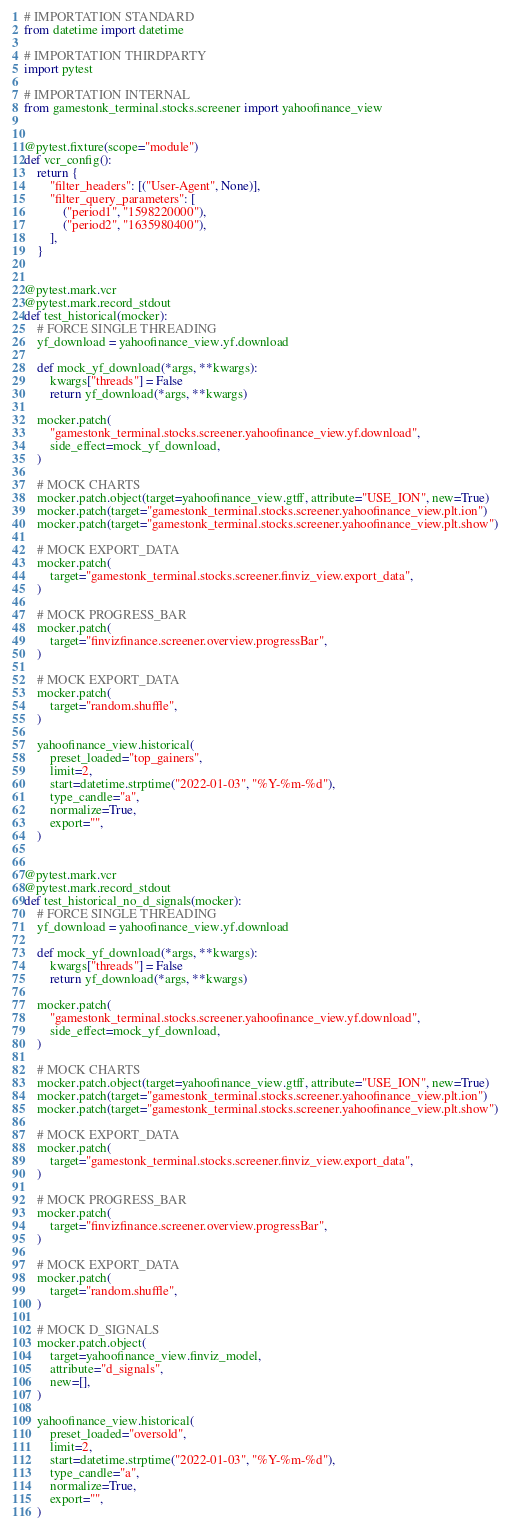<code> <loc_0><loc_0><loc_500><loc_500><_Python_># IMPORTATION STANDARD
from datetime import datetime

# IMPORTATION THIRDPARTY
import pytest

# IMPORTATION INTERNAL
from gamestonk_terminal.stocks.screener import yahoofinance_view


@pytest.fixture(scope="module")
def vcr_config():
    return {
        "filter_headers": [("User-Agent", None)],
        "filter_query_parameters": [
            ("period1", "1598220000"),
            ("period2", "1635980400"),
        ],
    }


@pytest.mark.vcr
@pytest.mark.record_stdout
def test_historical(mocker):
    # FORCE SINGLE THREADING
    yf_download = yahoofinance_view.yf.download

    def mock_yf_download(*args, **kwargs):
        kwargs["threads"] = False
        return yf_download(*args, **kwargs)

    mocker.patch(
        "gamestonk_terminal.stocks.screener.yahoofinance_view.yf.download",
        side_effect=mock_yf_download,
    )

    # MOCK CHARTS
    mocker.patch.object(target=yahoofinance_view.gtff, attribute="USE_ION", new=True)
    mocker.patch(target="gamestonk_terminal.stocks.screener.yahoofinance_view.plt.ion")
    mocker.patch(target="gamestonk_terminal.stocks.screener.yahoofinance_view.plt.show")

    # MOCK EXPORT_DATA
    mocker.patch(
        target="gamestonk_terminal.stocks.screener.finviz_view.export_data",
    )

    # MOCK PROGRESS_BAR
    mocker.patch(
        target="finvizfinance.screener.overview.progressBar",
    )

    # MOCK EXPORT_DATA
    mocker.patch(
        target="random.shuffle",
    )

    yahoofinance_view.historical(
        preset_loaded="top_gainers",
        limit=2,
        start=datetime.strptime("2022-01-03", "%Y-%m-%d"),
        type_candle="a",
        normalize=True,
        export="",
    )


@pytest.mark.vcr
@pytest.mark.record_stdout
def test_historical_no_d_signals(mocker):
    # FORCE SINGLE THREADING
    yf_download = yahoofinance_view.yf.download

    def mock_yf_download(*args, **kwargs):
        kwargs["threads"] = False
        return yf_download(*args, **kwargs)

    mocker.patch(
        "gamestonk_terminal.stocks.screener.yahoofinance_view.yf.download",
        side_effect=mock_yf_download,
    )

    # MOCK CHARTS
    mocker.patch.object(target=yahoofinance_view.gtff, attribute="USE_ION", new=True)
    mocker.patch(target="gamestonk_terminal.stocks.screener.yahoofinance_view.plt.ion")
    mocker.patch(target="gamestonk_terminal.stocks.screener.yahoofinance_view.plt.show")

    # MOCK EXPORT_DATA
    mocker.patch(
        target="gamestonk_terminal.stocks.screener.finviz_view.export_data",
    )

    # MOCK PROGRESS_BAR
    mocker.patch(
        target="finvizfinance.screener.overview.progressBar",
    )

    # MOCK EXPORT_DATA
    mocker.patch(
        target="random.shuffle",
    )

    # MOCK D_SIGNALS
    mocker.patch.object(
        target=yahoofinance_view.finviz_model,
        attribute="d_signals",
        new=[],
    )

    yahoofinance_view.historical(
        preset_loaded="oversold",
        limit=2,
        start=datetime.strptime("2022-01-03", "%Y-%m-%d"),
        type_candle="a",
        normalize=True,
        export="",
    )
</code> 